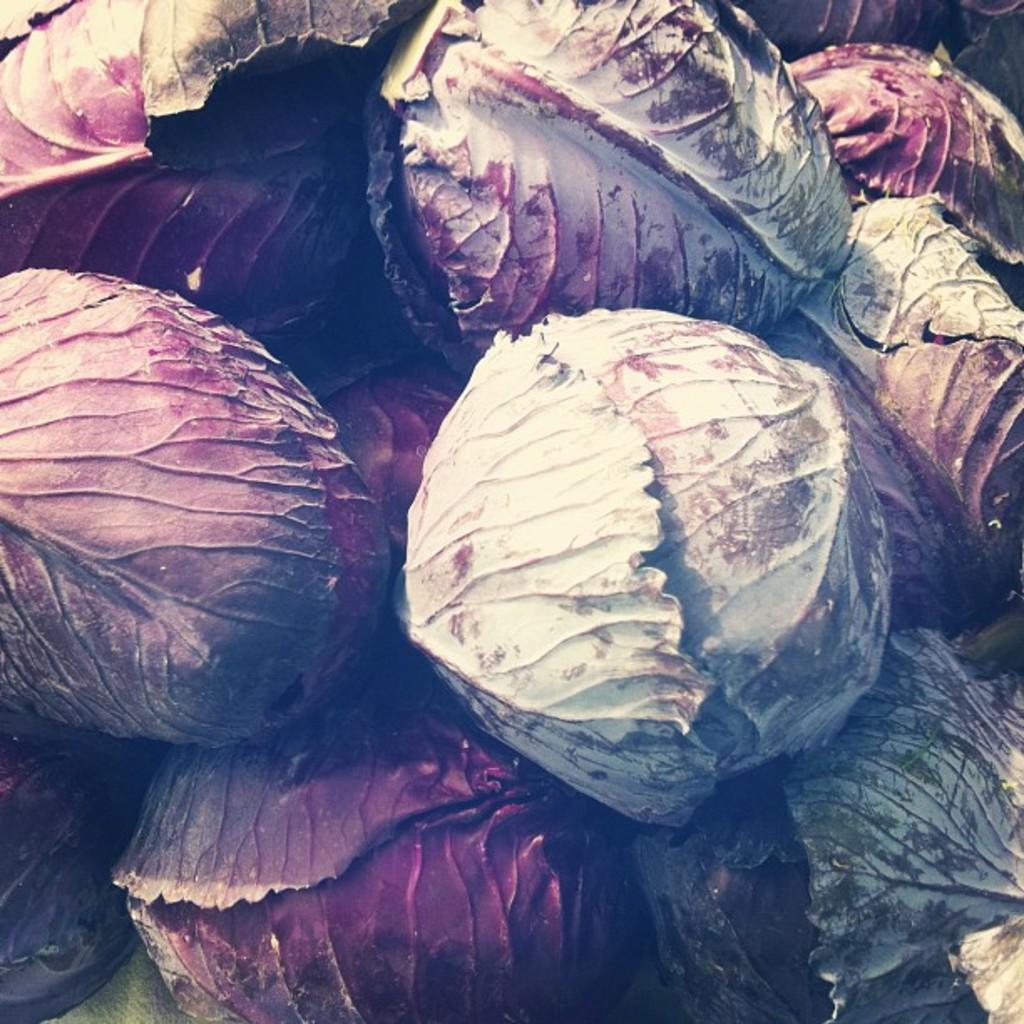Could you give a brief overview of what you see in this image? This picture consists of colorful cabbages. 